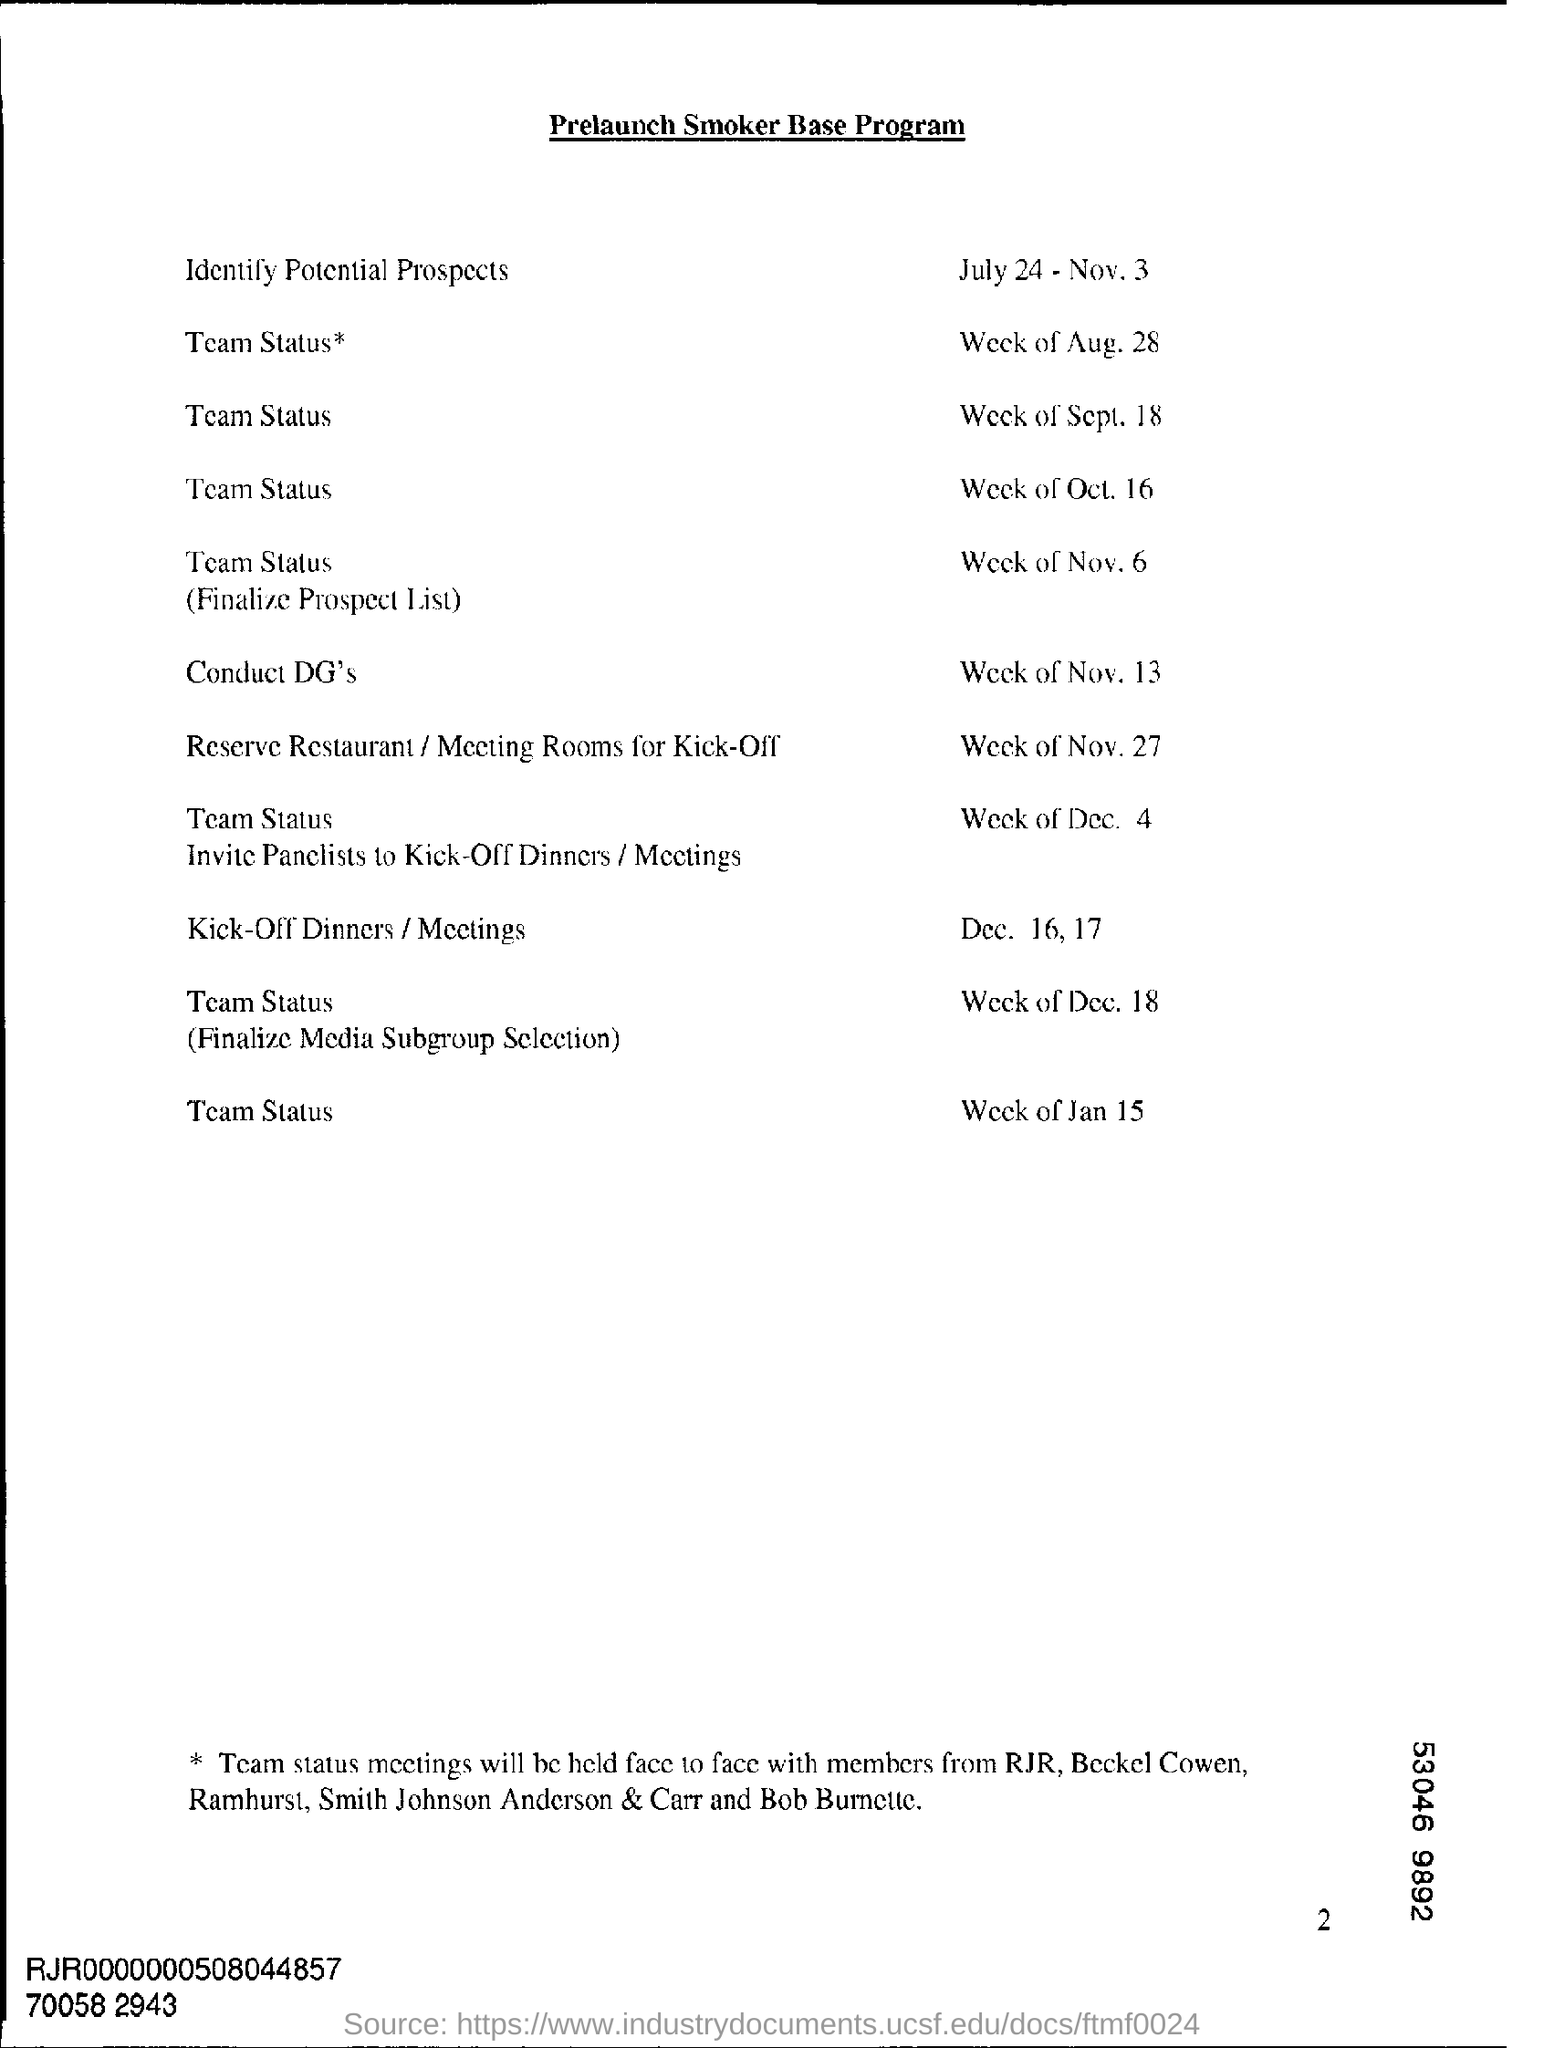Outline some significant characteristics in this image. The document's heading is "Prelaunch Smoker Base Program. The date mentioned for identifying potential prospects is July 24, 2023. 